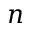Convert formula to latex. <formula><loc_0><loc_0><loc_500><loc_500>n</formula> 